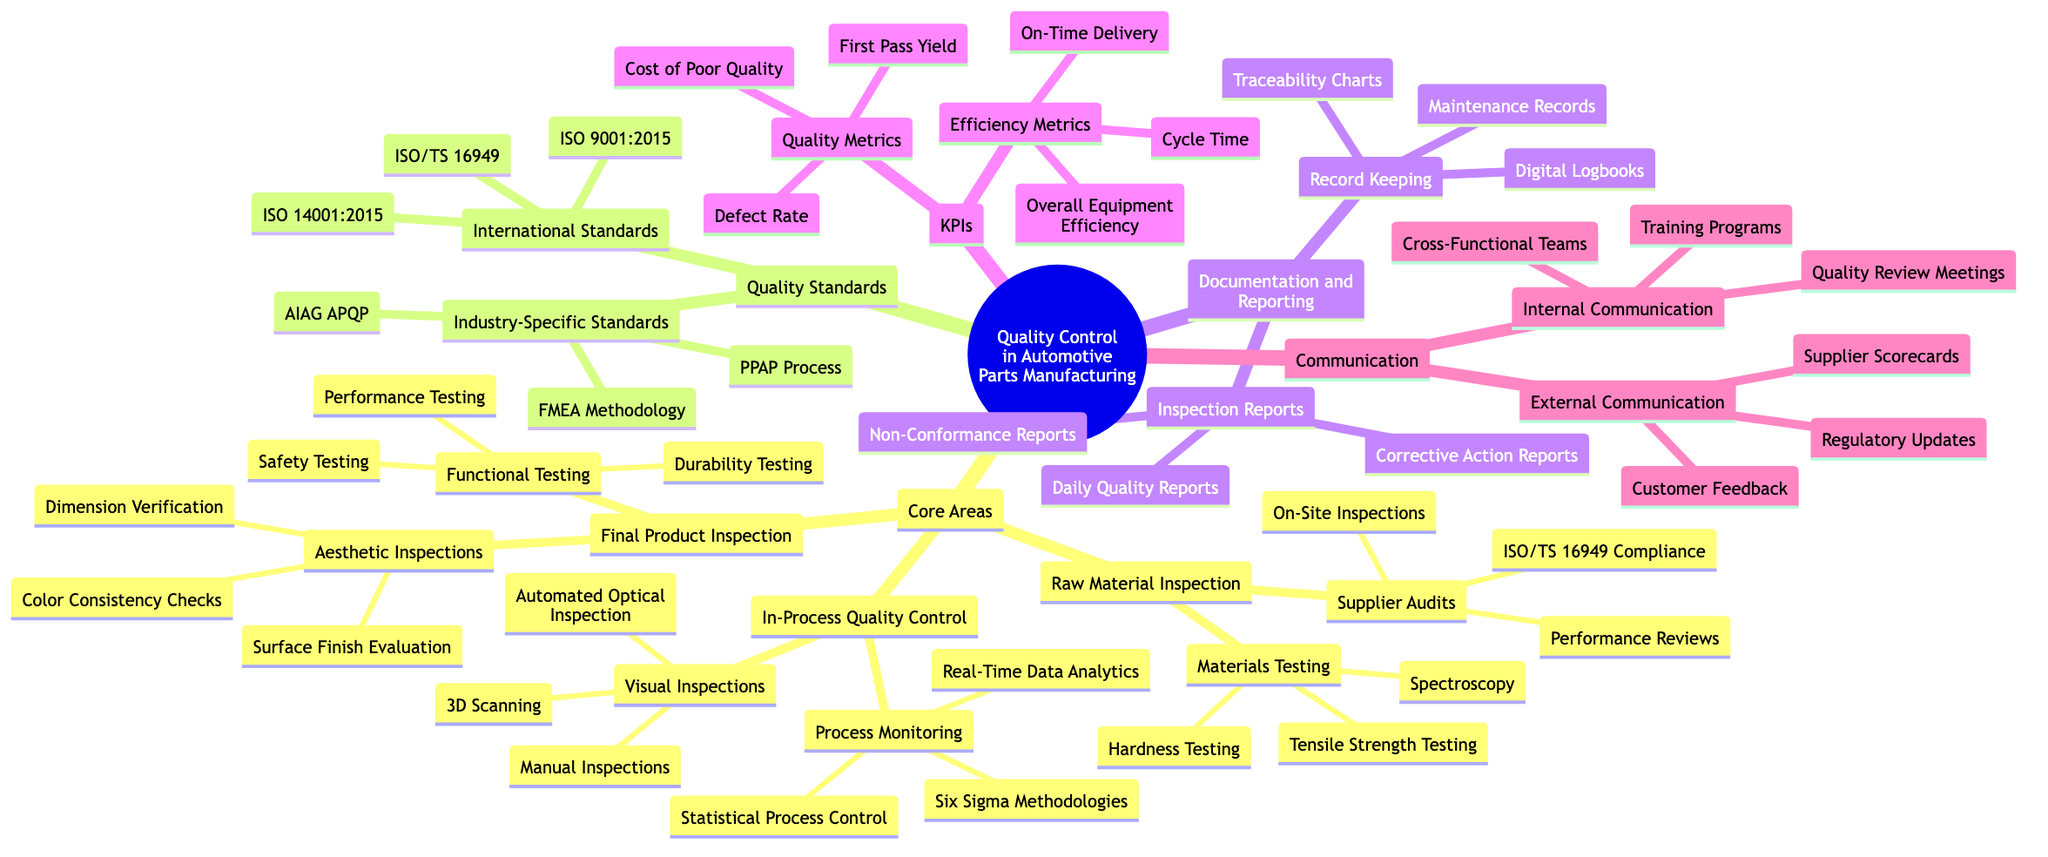What are the three types of materials testing listed? The diagram shows a node under "Raw Material Inspection" labeled "Materials Testing," which connects to three items: Spectroscopy, Tensile Strength Testing, and Hardness Testing. Thus, those are the three items listed.
Answer: Spectroscopy, Tensile Strength Testing, Hardness Testing What quality standard is specific to the automotive industry? Under the "Quality Standards" section, there is a subsection titled "Industry-Specific Standards" which contains three elements. One of these, titled "ISO/TS 16949," indicates a standard dedicated to the automotive industry.
Answer: ISO/TS 16949 How many types of final product inspection are mentioned? The section "Final Product Inspection" appears in the "Core Areas" module of the diagram, and under it, there are two subcategories: "Functional Testing" and "Aesthetic Inspections." This totals to two types mentioned under final product inspection.
Answer: 2 What is the highest level quality standard listed? The diagram categorizes quality standards into "International Standards" and "Industry-Specific Standards." Within the "International Standards," the first item listed is "ISO 9001:2015," which is generally regarded as a foundational quality standard, making it the highest level among those shown.
Answer: ISO 9001:2015 How many metrics are listed under quality metrics? The "KPIs" section breaks down into "Quality Metrics" and "Efficiency Metrics." Looking at "Quality Metrics," there are three specific items: Defect Rate, First Pass Yield, and Cost of Poor Quality, indicating there are three metrics listed here.
Answer: 3 What type of inspection is part of In-Process Quality Control? The "In-Process Quality Control" section identifies two primary components: "Process Monitoring" and "Visual Inspections." Visual Inspections include Automated Optical Inspection, Manual Inspections, and 3D Scanning as types. The question is about a type of inspection mentioned in this area. A clear example is "Automated Optical Inspection."
Answer: Automated Optical Inspection What is one communication method listed for internal communication? The "Communication" section is divided into "Internal Communication" and "External Communication." Within "Internal Communication," there are three methods including "Quality Review Meetings," "Cross-Functional Teams," and "Training Programs," any of which can be used as an answer. One viable option is "Quality Review Meetings."
Answer: Quality Review Meetings 